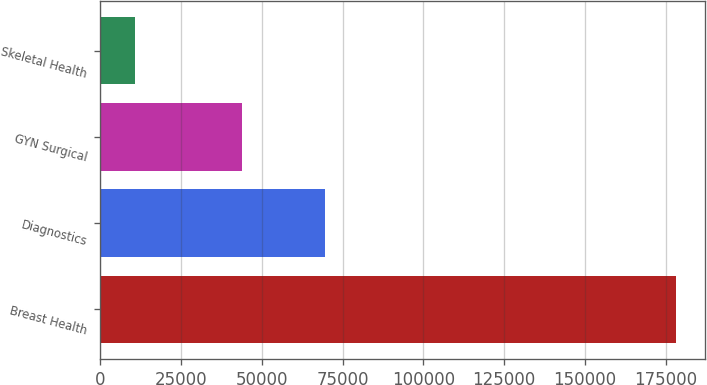<chart> <loc_0><loc_0><loc_500><loc_500><bar_chart><fcel>Breast Health<fcel>Diagnostics<fcel>GYN Surgical<fcel>Skeletal Health<nl><fcel>178202<fcel>69510<fcel>43882<fcel>10651<nl></chart> 